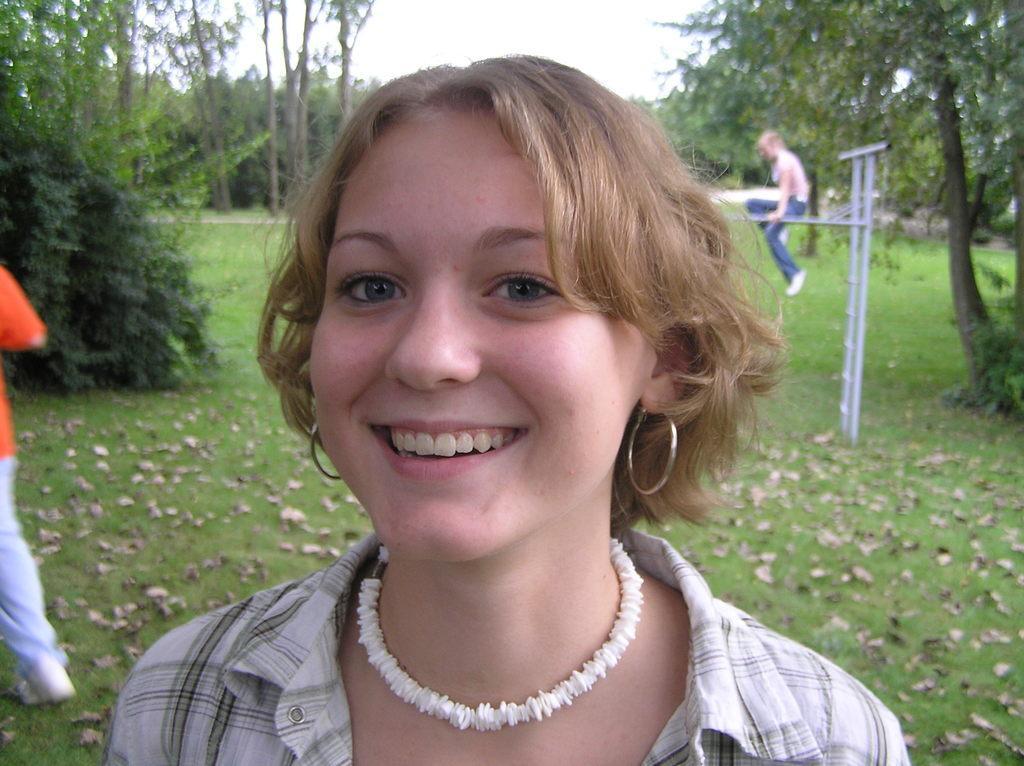In one or two sentences, can you explain what this image depicts? In this image we can see a lady wearing neck chain and earrings. In the back there are two persons. Also there is a ladder. On the ground there is grass and leaves. In the background there are trees. Also there is sky. 